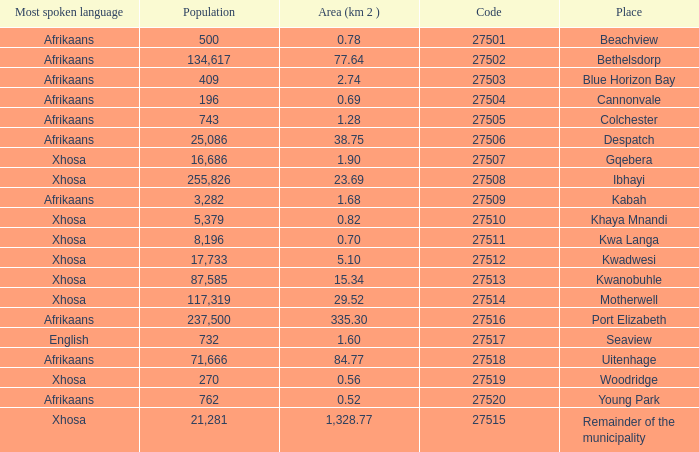What is the lowest code number for the remainder of the municipality that has an area bigger than 15.34 squared kilometers, a population greater than 762 and a language of xhosa spoken? 27515.0. 